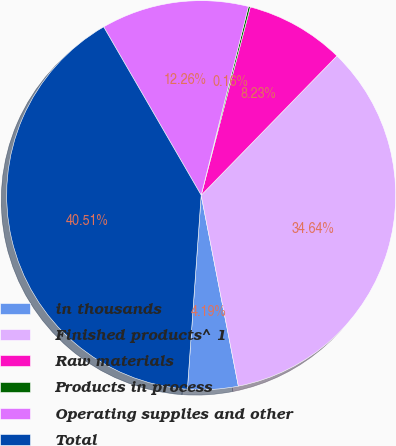<chart> <loc_0><loc_0><loc_500><loc_500><pie_chart><fcel>in thousands<fcel>Finished products^ 1<fcel>Raw materials<fcel>Products in process<fcel>Operating supplies and other<fcel>Total<nl><fcel>4.19%<fcel>34.64%<fcel>8.23%<fcel>0.16%<fcel>12.26%<fcel>40.51%<nl></chart> 